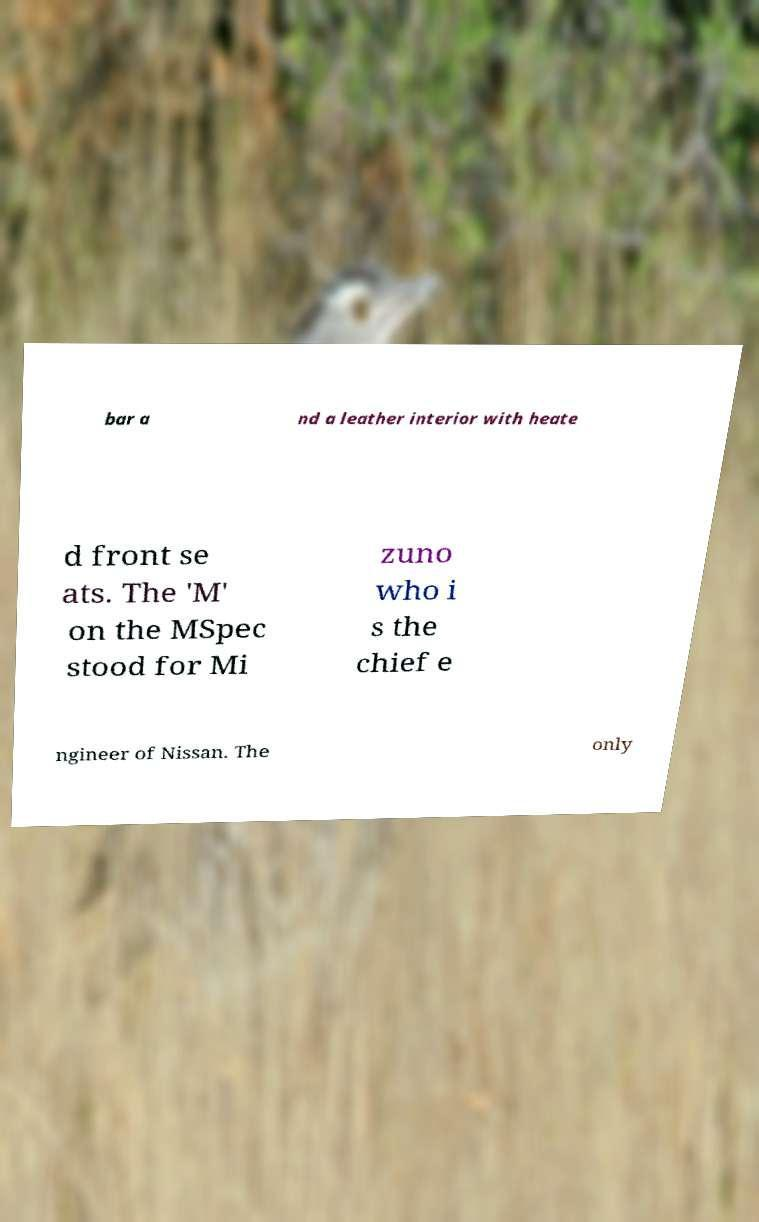For documentation purposes, I need the text within this image transcribed. Could you provide that? bar a nd a leather interior with heate d front se ats. The 'M' on the MSpec stood for Mi zuno who i s the chief e ngineer of Nissan. The only 